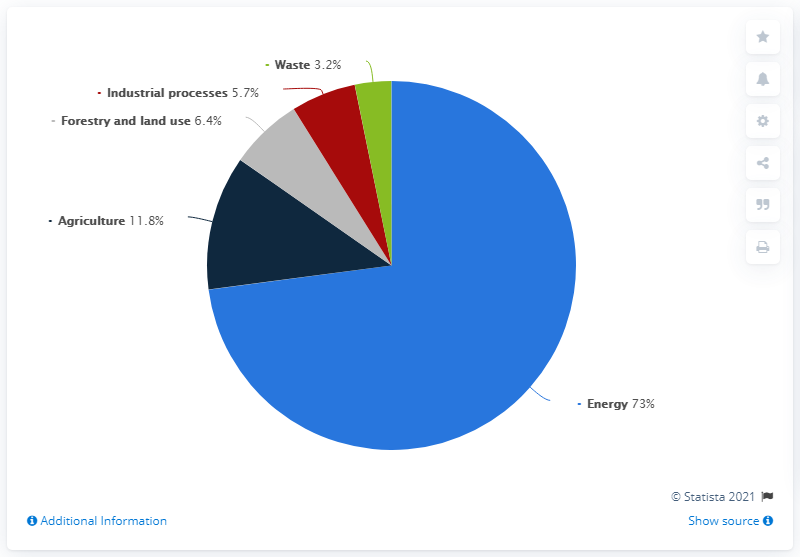Indicate a few pertinent items in this graphic. In 2017, the energy sector was responsible for 73% of global greenhouse gas emissions. The average of three least sectors is 5.1. The sector with the least share is waste. 